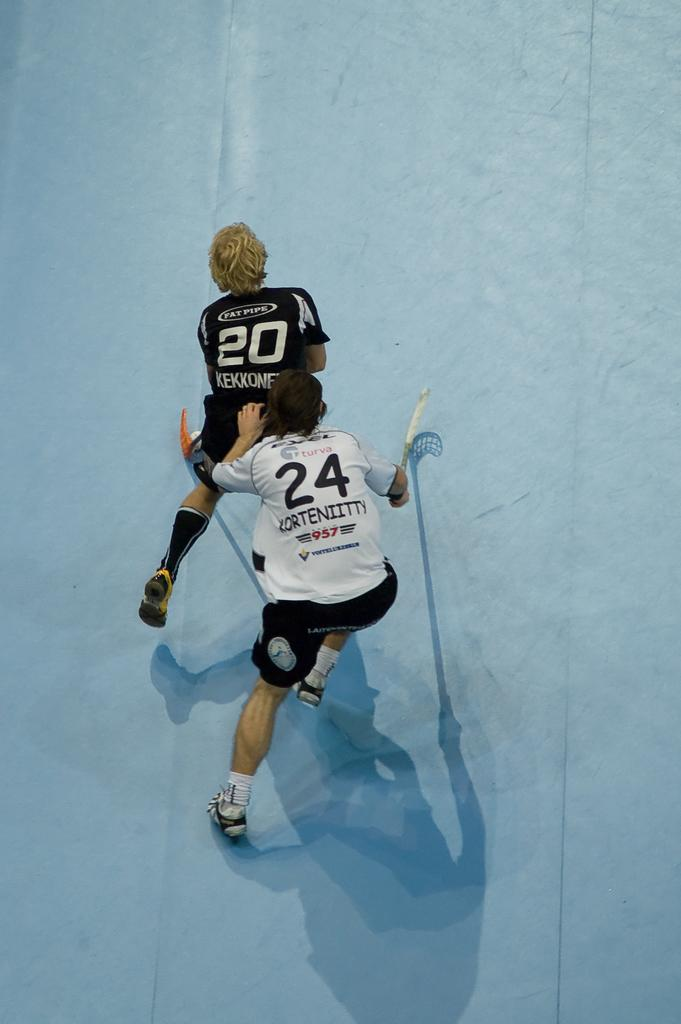<image>
Describe the image concisely. woman in white turva #24 jersey behind woman in black fatpipe #20 jersey 